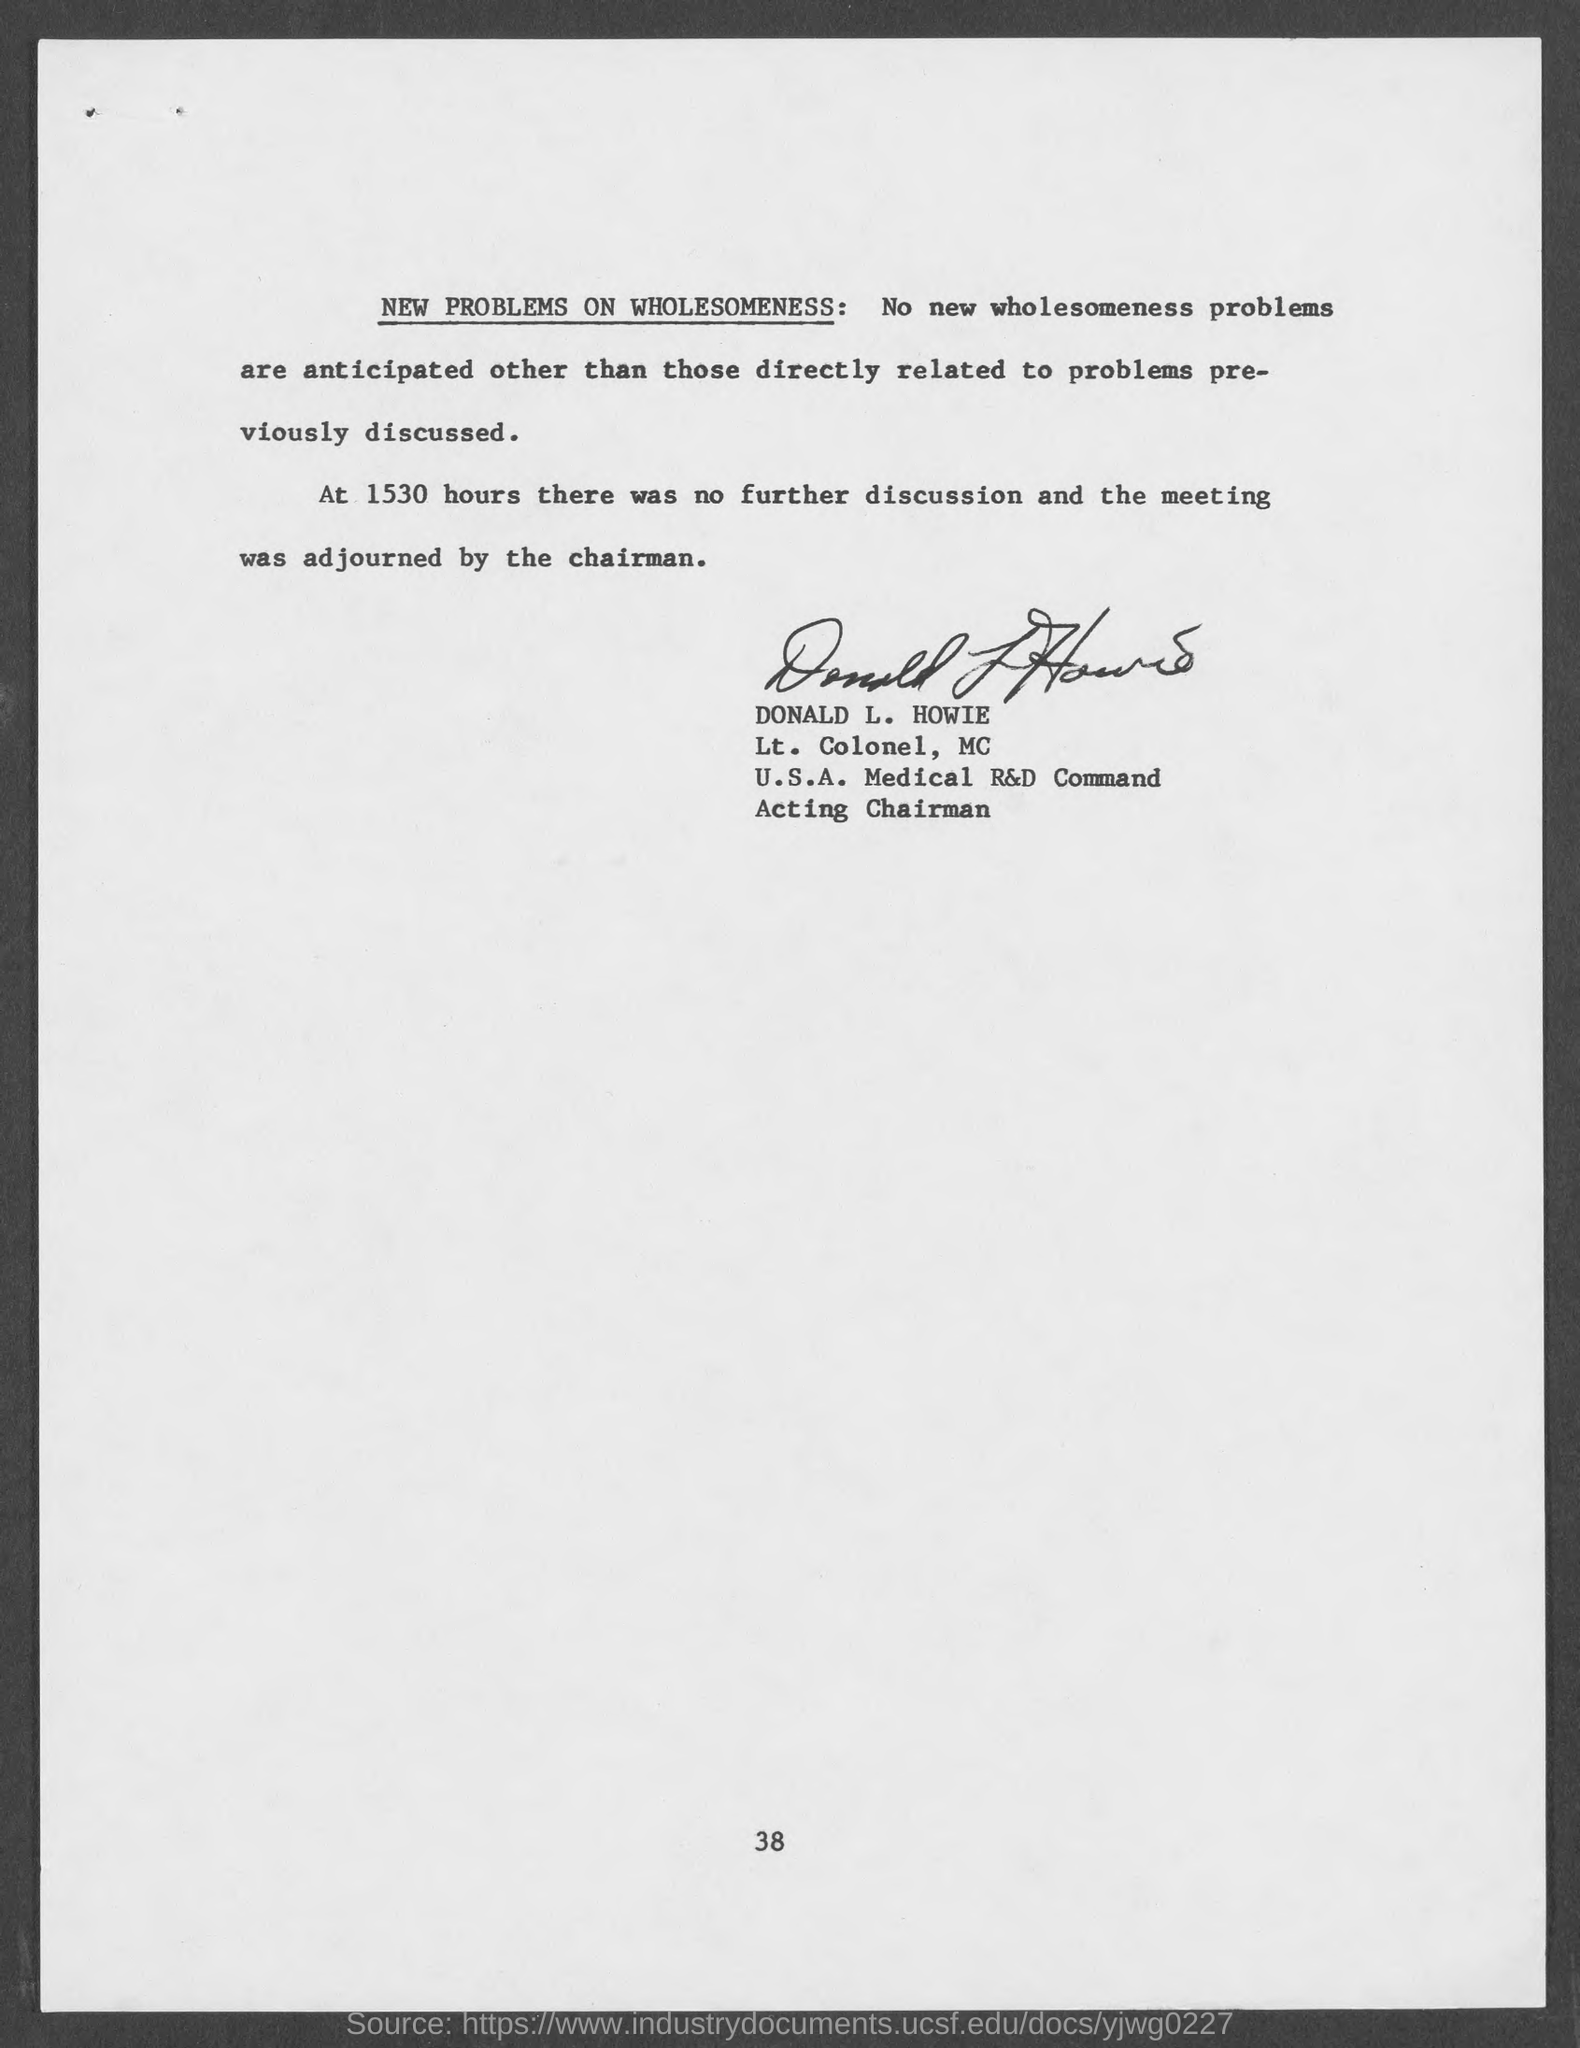List a handful of essential elements in this visual. On the bottom of the page, the page number is 38. Donald L. Howie is a Lt. Colonel, Military Cross. 